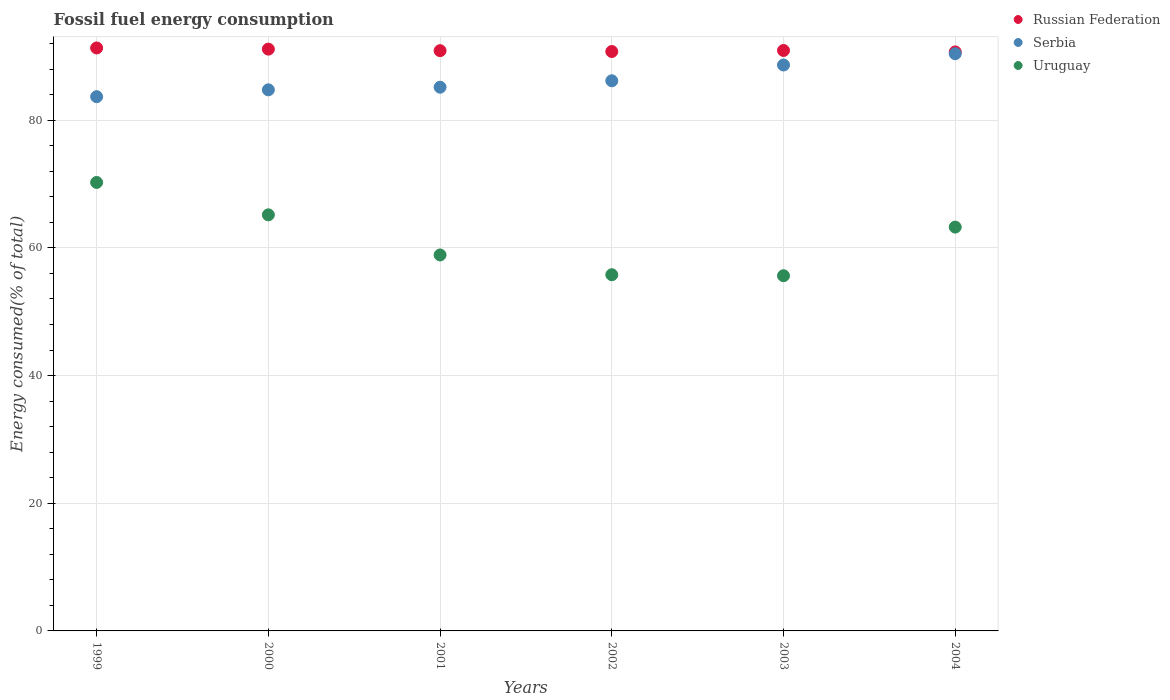Is the number of dotlines equal to the number of legend labels?
Offer a very short reply. Yes. What is the percentage of energy consumed in Russian Federation in 1999?
Your response must be concise. 91.31. Across all years, what is the maximum percentage of energy consumed in Uruguay?
Offer a very short reply. 70.25. Across all years, what is the minimum percentage of energy consumed in Russian Federation?
Provide a short and direct response. 90.69. In which year was the percentage of energy consumed in Russian Federation maximum?
Keep it short and to the point. 1999. What is the total percentage of energy consumed in Russian Federation in the graph?
Give a very brief answer. 545.68. What is the difference between the percentage of energy consumed in Russian Federation in 2000 and that in 2004?
Offer a very short reply. 0.44. What is the difference between the percentage of energy consumed in Russian Federation in 2002 and the percentage of energy consumed in Serbia in 2000?
Provide a short and direct response. 6. What is the average percentage of energy consumed in Russian Federation per year?
Offer a terse response. 90.95. In the year 1999, what is the difference between the percentage of energy consumed in Uruguay and percentage of energy consumed in Serbia?
Your response must be concise. -13.43. In how many years, is the percentage of energy consumed in Serbia greater than 40 %?
Offer a very short reply. 6. What is the ratio of the percentage of energy consumed in Russian Federation in 2002 to that in 2003?
Offer a terse response. 1. Is the percentage of energy consumed in Uruguay in 2000 less than that in 2001?
Give a very brief answer. No. Is the difference between the percentage of energy consumed in Uruguay in 1999 and 2000 greater than the difference between the percentage of energy consumed in Serbia in 1999 and 2000?
Give a very brief answer. Yes. What is the difference between the highest and the second highest percentage of energy consumed in Russian Federation?
Your answer should be very brief. 0.18. What is the difference between the highest and the lowest percentage of energy consumed in Serbia?
Offer a terse response. 6.73. In how many years, is the percentage of energy consumed in Serbia greater than the average percentage of energy consumed in Serbia taken over all years?
Your answer should be very brief. 2. Is it the case that in every year, the sum of the percentage of energy consumed in Uruguay and percentage of energy consumed in Serbia  is greater than the percentage of energy consumed in Russian Federation?
Make the answer very short. Yes. Is the percentage of energy consumed in Serbia strictly less than the percentage of energy consumed in Uruguay over the years?
Provide a succinct answer. No. How many dotlines are there?
Offer a terse response. 3. What is the difference between two consecutive major ticks on the Y-axis?
Provide a short and direct response. 20. Are the values on the major ticks of Y-axis written in scientific E-notation?
Offer a terse response. No. Does the graph contain grids?
Give a very brief answer. Yes. Where does the legend appear in the graph?
Give a very brief answer. Top right. How many legend labels are there?
Ensure brevity in your answer.  3. How are the legend labels stacked?
Your response must be concise. Vertical. What is the title of the graph?
Make the answer very short. Fossil fuel energy consumption. What is the label or title of the X-axis?
Provide a succinct answer. Years. What is the label or title of the Y-axis?
Ensure brevity in your answer.  Energy consumed(% of total). What is the Energy consumed(% of total) in Russian Federation in 1999?
Your answer should be very brief. 91.31. What is the Energy consumed(% of total) in Serbia in 1999?
Offer a very short reply. 83.68. What is the Energy consumed(% of total) of Uruguay in 1999?
Keep it short and to the point. 70.25. What is the Energy consumed(% of total) in Russian Federation in 2000?
Provide a succinct answer. 91.13. What is the Energy consumed(% of total) of Serbia in 2000?
Provide a short and direct response. 84.75. What is the Energy consumed(% of total) in Uruguay in 2000?
Provide a succinct answer. 65.17. What is the Energy consumed(% of total) of Russian Federation in 2001?
Provide a succinct answer. 90.89. What is the Energy consumed(% of total) in Serbia in 2001?
Provide a succinct answer. 85.16. What is the Energy consumed(% of total) in Uruguay in 2001?
Offer a terse response. 58.89. What is the Energy consumed(% of total) in Russian Federation in 2002?
Make the answer very short. 90.75. What is the Energy consumed(% of total) of Serbia in 2002?
Make the answer very short. 86.17. What is the Energy consumed(% of total) of Uruguay in 2002?
Provide a succinct answer. 55.79. What is the Energy consumed(% of total) in Russian Federation in 2003?
Provide a short and direct response. 90.92. What is the Energy consumed(% of total) of Serbia in 2003?
Make the answer very short. 88.64. What is the Energy consumed(% of total) of Uruguay in 2003?
Keep it short and to the point. 55.63. What is the Energy consumed(% of total) in Russian Federation in 2004?
Your response must be concise. 90.69. What is the Energy consumed(% of total) of Serbia in 2004?
Give a very brief answer. 90.41. What is the Energy consumed(% of total) in Uruguay in 2004?
Keep it short and to the point. 63.25. Across all years, what is the maximum Energy consumed(% of total) of Russian Federation?
Keep it short and to the point. 91.31. Across all years, what is the maximum Energy consumed(% of total) of Serbia?
Offer a terse response. 90.41. Across all years, what is the maximum Energy consumed(% of total) in Uruguay?
Give a very brief answer. 70.25. Across all years, what is the minimum Energy consumed(% of total) of Russian Federation?
Ensure brevity in your answer.  90.69. Across all years, what is the minimum Energy consumed(% of total) of Serbia?
Keep it short and to the point. 83.68. Across all years, what is the minimum Energy consumed(% of total) in Uruguay?
Ensure brevity in your answer.  55.63. What is the total Energy consumed(% of total) in Russian Federation in the graph?
Your response must be concise. 545.68. What is the total Energy consumed(% of total) of Serbia in the graph?
Keep it short and to the point. 518.81. What is the total Energy consumed(% of total) of Uruguay in the graph?
Provide a short and direct response. 368.98. What is the difference between the Energy consumed(% of total) in Russian Federation in 1999 and that in 2000?
Ensure brevity in your answer.  0.18. What is the difference between the Energy consumed(% of total) in Serbia in 1999 and that in 2000?
Your answer should be compact. -1.07. What is the difference between the Energy consumed(% of total) of Uruguay in 1999 and that in 2000?
Your answer should be compact. 5.07. What is the difference between the Energy consumed(% of total) in Russian Federation in 1999 and that in 2001?
Ensure brevity in your answer.  0.42. What is the difference between the Energy consumed(% of total) of Serbia in 1999 and that in 2001?
Your answer should be compact. -1.48. What is the difference between the Energy consumed(% of total) of Uruguay in 1999 and that in 2001?
Keep it short and to the point. 11.36. What is the difference between the Energy consumed(% of total) of Russian Federation in 1999 and that in 2002?
Give a very brief answer. 0.56. What is the difference between the Energy consumed(% of total) in Serbia in 1999 and that in 2002?
Make the answer very short. -2.49. What is the difference between the Energy consumed(% of total) in Uruguay in 1999 and that in 2002?
Provide a succinct answer. 14.46. What is the difference between the Energy consumed(% of total) in Russian Federation in 1999 and that in 2003?
Give a very brief answer. 0.39. What is the difference between the Energy consumed(% of total) in Serbia in 1999 and that in 2003?
Your answer should be compact. -4.96. What is the difference between the Energy consumed(% of total) in Uruguay in 1999 and that in 2003?
Provide a short and direct response. 14.61. What is the difference between the Energy consumed(% of total) of Russian Federation in 1999 and that in 2004?
Offer a terse response. 0.62. What is the difference between the Energy consumed(% of total) of Serbia in 1999 and that in 2004?
Your answer should be very brief. -6.73. What is the difference between the Energy consumed(% of total) in Uruguay in 1999 and that in 2004?
Make the answer very short. 6.99. What is the difference between the Energy consumed(% of total) of Russian Federation in 2000 and that in 2001?
Give a very brief answer. 0.24. What is the difference between the Energy consumed(% of total) of Serbia in 2000 and that in 2001?
Offer a very short reply. -0.41. What is the difference between the Energy consumed(% of total) of Uruguay in 2000 and that in 2001?
Offer a terse response. 6.29. What is the difference between the Energy consumed(% of total) of Russian Federation in 2000 and that in 2002?
Offer a terse response. 0.37. What is the difference between the Energy consumed(% of total) in Serbia in 2000 and that in 2002?
Offer a terse response. -1.42. What is the difference between the Energy consumed(% of total) in Uruguay in 2000 and that in 2002?
Your answer should be very brief. 9.38. What is the difference between the Energy consumed(% of total) of Russian Federation in 2000 and that in 2003?
Your answer should be very brief. 0.21. What is the difference between the Energy consumed(% of total) of Serbia in 2000 and that in 2003?
Make the answer very short. -3.89. What is the difference between the Energy consumed(% of total) in Uruguay in 2000 and that in 2003?
Give a very brief answer. 9.54. What is the difference between the Energy consumed(% of total) of Russian Federation in 2000 and that in 2004?
Your answer should be very brief. 0.44. What is the difference between the Energy consumed(% of total) of Serbia in 2000 and that in 2004?
Keep it short and to the point. -5.66. What is the difference between the Energy consumed(% of total) of Uruguay in 2000 and that in 2004?
Give a very brief answer. 1.92. What is the difference between the Energy consumed(% of total) of Russian Federation in 2001 and that in 2002?
Offer a very short reply. 0.13. What is the difference between the Energy consumed(% of total) of Serbia in 2001 and that in 2002?
Offer a terse response. -1. What is the difference between the Energy consumed(% of total) of Uruguay in 2001 and that in 2002?
Give a very brief answer. 3.1. What is the difference between the Energy consumed(% of total) of Russian Federation in 2001 and that in 2003?
Give a very brief answer. -0.03. What is the difference between the Energy consumed(% of total) in Serbia in 2001 and that in 2003?
Give a very brief answer. -3.48. What is the difference between the Energy consumed(% of total) in Uruguay in 2001 and that in 2003?
Provide a succinct answer. 3.25. What is the difference between the Energy consumed(% of total) of Russian Federation in 2001 and that in 2004?
Keep it short and to the point. 0.2. What is the difference between the Energy consumed(% of total) of Serbia in 2001 and that in 2004?
Offer a very short reply. -5.25. What is the difference between the Energy consumed(% of total) of Uruguay in 2001 and that in 2004?
Offer a terse response. -4.36. What is the difference between the Energy consumed(% of total) in Russian Federation in 2002 and that in 2003?
Provide a succinct answer. -0.16. What is the difference between the Energy consumed(% of total) of Serbia in 2002 and that in 2003?
Ensure brevity in your answer.  -2.47. What is the difference between the Energy consumed(% of total) in Uruguay in 2002 and that in 2003?
Ensure brevity in your answer.  0.16. What is the difference between the Energy consumed(% of total) of Russian Federation in 2002 and that in 2004?
Provide a short and direct response. 0.06. What is the difference between the Energy consumed(% of total) of Serbia in 2002 and that in 2004?
Provide a short and direct response. -4.24. What is the difference between the Energy consumed(% of total) in Uruguay in 2002 and that in 2004?
Provide a short and direct response. -7.46. What is the difference between the Energy consumed(% of total) in Russian Federation in 2003 and that in 2004?
Your answer should be very brief. 0.23. What is the difference between the Energy consumed(% of total) of Serbia in 2003 and that in 2004?
Ensure brevity in your answer.  -1.77. What is the difference between the Energy consumed(% of total) of Uruguay in 2003 and that in 2004?
Provide a succinct answer. -7.62. What is the difference between the Energy consumed(% of total) of Russian Federation in 1999 and the Energy consumed(% of total) of Serbia in 2000?
Your answer should be very brief. 6.56. What is the difference between the Energy consumed(% of total) in Russian Federation in 1999 and the Energy consumed(% of total) in Uruguay in 2000?
Offer a very short reply. 26.14. What is the difference between the Energy consumed(% of total) of Serbia in 1999 and the Energy consumed(% of total) of Uruguay in 2000?
Your answer should be compact. 18.5. What is the difference between the Energy consumed(% of total) of Russian Federation in 1999 and the Energy consumed(% of total) of Serbia in 2001?
Offer a very short reply. 6.15. What is the difference between the Energy consumed(% of total) in Russian Federation in 1999 and the Energy consumed(% of total) in Uruguay in 2001?
Provide a succinct answer. 32.42. What is the difference between the Energy consumed(% of total) in Serbia in 1999 and the Energy consumed(% of total) in Uruguay in 2001?
Provide a succinct answer. 24.79. What is the difference between the Energy consumed(% of total) of Russian Federation in 1999 and the Energy consumed(% of total) of Serbia in 2002?
Offer a very short reply. 5.14. What is the difference between the Energy consumed(% of total) of Russian Federation in 1999 and the Energy consumed(% of total) of Uruguay in 2002?
Make the answer very short. 35.52. What is the difference between the Energy consumed(% of total) in Serbia in 1999 and the Energy consumed(% of total) in Uruguay in 2002?
Your answer should be compact. 27.89. What is the difference between the Energy consumed(% of total) of Russian Federation in 1999 and the Energy consumed(% of total) of Serbia in 2003?
Ensure brevity in your answer.  2.67. What is the difference between the Energy consumed(% of total) of Russian Federation in 1999 and the Energy consumed(% of total) of Uruguay in 2003?
Make the answer very short. 35.67. What is the difference between the Energy consumed(% of total) in Serbia in 1999 and the Energy consumed(% of total) in Uruguay in 2003?
Give a very brief answer. 28.04. What is the difference between the Energy consumed(% of total) in Russian Federation in 1999 and the Energy consumed(% of total) in Serbia in 2004?
Keep it short and to the point. 0.9. What is the difference between the Energy consumed(% of total) of Russian Federation in 1999 and the Energy consumed(% of total) of Uruguay in 2004?
Keep it short and to the point. 28.06. What is the difference between the Energy consumed(% of total) of Serbia in 1999 and the Energy consumed(% of total) of Uruguay in 2004?
Your answer should be compact. 20.43. What is the difference between the Energy consumed(% of total) in Russian Federation in 2000 and the Energy consumed(% of total) in Serbia in 2001?
Keep it short and to the point. 5.96. What is the difference between the Energy consumed(% of total) in Russian Federation in 2000 and the Energy consumed(% of total) in Uruguay in 2001?
Make the answer very short. 32.24. What is the difference between the Energy consumed(% of total) of Serbia in 2000 and the Energy consumed(% of total) of Uruguay in 2001?
Keep it short and to the point. 25.86. What is the difference between the Energy consumed(% of total) in Russian Federation in 2000 and the Energy consumed(% of total) in Serbia in 2002?
Your answer should be very brief. 4.96. What is the difference between the Energy consumed(% of total) in Russian Federation in 2000 and the Energy consumed(% of total) in Uruguay in 2002?
Your response must be concise. 35.34. What is the difference between the Energy consumed(% of total) of Serbia in 2000 and the Energy consumed(% of total) of Uruguay in 2002?
Keep it short and to the point. 28.96. What is the difference between the Energy consumed(% of total) in Russian Federation in 2000 and the Energy consumed(% of total) in Serbia in 2003?
Offer a terse response. 2.48. What is the difference between the Energy consumed(% of total) in Russian Federation in 2000 and the Energy consumed(% of total) in Uruguay in 2003?
Keep it short and to the point. 35.49. What is the difference between the Energy consumed(% of total) in Serbia in 2000 and the Energy consumed(% of total) in Uruguay in 2003?
Your answer should be very brief. 29.12. What is the difference between the Energy consumed(% of total) of Russian Federation in 2000 and the Energy consumed(% of total) of Serbia in 2004?
Your answer should be very brief. 0.72. What is the difference between the Energy consumed(% of total) in Russian Federation in 2000 and the Energy consumed(% of total) in Uruguay in 2004?
Give a very brief answer. 27.88. What is the difference between the Energy consumed(% of total) of Serbia in 2000 and the Energy consumed(% of total) of Uruguay in 2004?
Offer a very short reply. 21.5. What is the difference between the Energy consumed(% of total) in Russian Federation in 2001 and the Energy consumed(% of total) in Serbia in 2002?
Give a very brief answer. 4.72. What is the difference between the Energy consumed(% of total) of Russian Federation in 2001 and the Energy consumed(% of total) of Uruguay in 2002?
Keep it short and to the point. 35.1. What is the difference between the Energy consumed(% of total) of Serbia in 2001 and the Energy consumed(% of total) of Uruguay in 2002?
Give a very brief answer. 29.37. What is the difference between the Energy consumed(% of total) of Russian Federation in 2001 and the Energy consumed(% of total) of Serbia in 2003?
Your answer should be compact. 2.24. What is the difference between the Energy consumed(% of total) of Russian Federation in 2001 and the Energy consumed(% of total) of Uruguay in 2003?
Make the answer very short. 35.25. What is the difference between the Energy consumed(% of total) of Serbia in 2001 and the Energy consumed(% of total) of Uruguay in 2003?
Your answer should be very brief. 29.53. What is the difference between the Energy consumed(% of total) of Russian Federation in 2001 and the Energy consumed(% of total) of Serbia in 2004?
Give a very brief answer. 0.48. What is the difference between the Energy consumed(% of total) in Russian Federation in 2001 and the Energy consumed(% of total) in Uruguay in 2004?
Your answer should be very brief. 27.64. What is the difference between the Energy consumed(% of total) of Serbia in 2001 and the Energy consumed(% of total) of Uruguay in 2004?
Give a very brief answer. 21.91. What is the difference between the Energy consumed(% of total) in Russian Federation in 2002 and the Energy consumed(% of total) in Serbia in 2003?
Offer a very short reply. 2.11. What is the difference between the Energy consumed(% of total) of Russian Federation in 2002 and the Energy consumed(% of total) of Uruguay in 2003?
Provide a succinct answer. 35.12. What is the difference between the Energy consumed(% of total) in Serbia in 2002 and the Energy consumed(% of total) in Uruguay in 2003?
Make the answer very short. 30.53. What is the difference between the Energy consumed(% of total) in Russian Federation in 2002 and the Energy consumed(% of total) in Serbia in 2004?
Keep it short and to the point. 0.34. What is the difference between the Energy consumed(% of total) of Russian Federation in 2002 and the Energy consumed(% of total) of Uruguay in 2004?
Keep it short and to the point. 27.5. What is the difference between the Energy consumed(% of total) in Serbia in 2002 and the Energy consumed(% of total) in Uruguay in 2004?
Provide a short and direct response. 22.92. What is the difference between the Energy consumed(% of total) of Russian Federation in 2003 and the Energy consumed(% of total) of Serbia in 2004?
Your answer should be very brief. 0.51. What is the difference between the Energy consumed(% of total) of Russian Federation in 2003 and the Energy consumed(% of total) of Uruguay in 2004?
Provide a succinct answer. 27.66. What is the difference between the Energy consumed(% of total) in Serbia in 2003 and the Energy consumed(% of total) in Uruguay in 2004?
Provide a short and direct response. 25.39. What is the average Energy consumed(% of total) in Russian Federation per year?
Your answer should be very brief. 90.95. What is the average Energy consumed(% of total) in Serbia per year?
Make the answer very short. 86.47. What is the average Energy consumed(% of total) in Uruguay per year?
Your answer should be compact. 61.5. In the year 1999, what is the difference between the Energy consumed(% of total) of Russian Federation and Energy consumed(% of total) of Serbia?
Give a very brief answer. 7.63. In the year 1999, what is the difference between the Energy consumed(% of total) in Russian Federation and Energy consumed(% of total) in Uruguay?
Keep it short and to the point. 21.06. In the year 1999, what is the difference between the Energy consumed(% of total) in Serbia and Energy consumed(% of total) in Uruguay?
Your answer should be compact. 13.43. In the year 2000, what is the difference between the Energy consumed(% of total) in Russian Federation and Energy consumed(% of total) in Serbia?
Your answer should be compact. 6.37. In the year 2000, what is the difference between the Energy consumed(% of total) in Russian Federation and Energy consumed(% of total) in Uruguay?
Offer a very short reply. 25.95. In the year 2000, what is the difference between the Energy consumed(% of total) in Serbia and Energy consumed(% of total) in Uruguay?
Give a very brief answer. 19.58. In the year 2001, what is the difference between the Energy consumed(% of total) in Russian Federation and Energy consumed(% of total) in Serbia?
Provide a short and direct response. 5.72. In the year 2001, what is the difference between the Energy consumed(% of total) in Russian Federation and Energy consumed(% of total) in Uruguay?
Offer a terse response. 32. In the year 2001, what is the difference between the Energy consumed(% of total) in Serbia and Energy consumed(% of total) in Uruguay?
Offer a very short reply. 26.27. In the year 2002, what is the difference between the Energy consumed(% of total) in Russian Federation and Energy consumed(% of total) in Serbia?
Offer a very short reply. 4.59. In the year 2002, what is the difference between the Energy consumed(% of total) in Russian Federation and Energy consumed(% of total) in Uruguay?
Give a very brief answer. 34.96. In the year 2002, what is the difference between the Energy consumed(% of total) of Serbia and Energy consumed(% of total) of Uruguay?
Your response must be concise. 30.38. In the year 2003, what is the difference between the Energy consumed(% of total) in Russian Federation and Energy consumed(% of total) in Serbia?
Give a very brief answer. 2.27. In the year 2003, what is the difference between the Energy consumed(% of total) of Russian Federation and Energy consumed(% of total) of Uruguay?
Offer a terse response. 35.28. In the year 2003, what is the difference between the Energy consumed(% of total) of Serbia and Energy consumed(% of total) of Uruguay?
Make the answer very short. 33.01. In the year 2004, what is the difference between the Energy consumed(% of total) in Russian Federation and Energy consumed(% of total) in Serbia?
Your answer should be very brief. 0.28. In the year 2004, what is the difference between the Energy consumed(% of total) of Russian Federation and Energy consumed(% of total) of Uruguay?
Your response must be concise. 27.44. In the year 2004, what is the difference between the Energy consumed(% of total) in Serbia and Energy consumed(% of total) in Uruguay?
Keep it short and to the point. 27.16. What is the ratio of the Energy consumed(% of total) in Russian Federation in 1999 to that in 2000?
Your response must be concise. 1. What is the ratio of the Energy consumed(% of total) of Serbia in 1999 to that in 2000?
Provide a succinct answer. 0.99. What is the ratio of the Energy consumed(% of total) in Uruguay in 1999 to that in 2000?
Offer a terse response. 1.08. What is the ratio of the Energy consumed(% of total) of Russian Federation in 1999 to that in 2001?
Make the answer very short. 1. What is the ratio of the Energy consumed(% of total) of Serbia in 1999 to that in 2001?
Offer a terse response. 0.98. What is the ratio of the Energy consumed(% of total) in Uruguay in 1999 to that in 2001?
Provide a short and direct response. 1.19. What is the ratio of the Energy consumed(% of total) of Russian Federation in 1999 to that in 2002?
Your answer should be very brief. 1.01. What is the ratio of the Energy consumed(% of total) of Serbia in 1999 to that in 2002?
Offer a terse response. 0.97. What is the ratio of the Energy consumed(% of total) in Uruguay in 1999 to that in 2002?
Make the answer very short. 1.26. What is the ratio of the Energy consumed(% of total) of Russian Federation in 1999 to that in 2003?
Offer a very short reply. 1. What is the ratio of the Energy consumed(% of total) of Serbia in 1999 to that in 2003?
Provide a succinct answer. 0.94. What is the ratio of the Energy consumed(% of total) of Uruguay in 1999 to that in 2003?
Your answer should be compact. 1.26. What is the ratio of the Energy consumed(% of total) of Russian Federation in 1999 to that in 2004?
Provide a short and direct response. 1.01. What is the ratio of the Energy consumed(% of total) of Serbia in 1999 to that in 2004?
Provide a short and direct response. 0.93. What is the ratio of the Energy consumed(% of total) of Uruguay in 1999 to that in 2004?
Make the answer very short. 1.11. What is the ratio of the Energy consumed(% of total) in Serbia in 2000 to that in 2001?
Keep it short and to the point. 1. What is the ratio of the Energy consumed(% of total) in Uruguay in 2000 to that in 2001?
Offer a very short reply. 1.11. What is the ratio of the Energy consumed(% of total) of Russian Federation in 2000 to that in 2002?
Make the answer very short. 1. What is the ratio of the Energy consumed(% of total) in Serbia in 2000 to that in 2002?
Offer a very short reply. 0.98. What is the ratio of the Energy consumed(% of total) in Uruguay in 2000 to that in 2002?
Give a very brief answer. 1.17. What is the ratio of the Energy consumed(% of total) in Serbia in 2000 to that in 2003?
Offer a very short reply. 0.96. What is the ratio of the Energy consumed(% of total) of Uruguay in 2000 to that in 2003?
Offer a very short reply. 1.17. What is the ratio of the Energy consumed(% of total) of Russian Federation in 2000 to that in 2004?
Make the answer very short. 1. What is the ratio of the Energy consumed(% of total) in Serbia in 2000 to that in 2004?
Offer a terse response. 0.94. What is the ratio of the Energy consumed(% of total) of Uruguay in 2000 to that in 2004?
Offer a very short reply. 1.03. What is the ratio of the Energy consumed(% of total) in Russian Federation in 2001 to that in 2002?
Your response must be concise. 1. What is the ratio of the Energy consumed(% of total) of Serbia in 2001 to that in 2002?
Keep it short and to the point. 0.99. What is the ratio of the Energy consumed(% of total) in Uruguay in 2001 to that in 2002?
Offer a terse response. 1.06. What is the ratio of the Energy consumed(% of total) of Russian Federation in 2001 to that in 2003?
Offer a terse response. 1. What is the ratio of the Energy consumed(% of total) of Serbia in 2001 to that in 2003?
Your answer should be compact. 0.96. What is the ratio of the Energy consumed(% of total) in Uruguay in 2001 to that in 2003?
Offer a terse response. 1.06. What is the ratio of the Energy consumed(% of total) of Russian Federation in 2001 to that in 2004?
Provide a succinct answer. 1. What is the ratio of the Energy consumed(% of total) of Serbia in 2001 to that in 2004?
Your answer should be very brief. 0.94. What is the ratio of the Energy consumed(% of total) in Uruguay in 2001 to that in 2004?
Keep it short and to the point. 0.93. What is the ratio of the Energy consumed(% of total) of Serbia in 2002 to that in 2003?
Keep it short and to the point. 0.97. What is the ratio of the Energy consumed(% of total) in Russian Federation in 2002 to that in 2004?
Provide a short and direct response. 1. What is the ratio of the Energy consumed(% of total) in Serbia in 2002 to that in 2004?
Keep it short and to the point. 0.95. What is the ratio of the Energy consumed(% of total) in Uruguay in 2002 to that in 2004?
Your response must be concise. 0.88. What is the ratio of the Energy consumed(% of total) in Serbia in 2003 to that in 2004?
Provide a short and direct response. 0.98. What is the ratio of the Energy consumed(% of total) in Uruguay in 2003 to that in 2004?
Give a very brief answer. 0.88. What is the difference between the highest and the second highest Energy consumed(% of total) in Russian Federation?
Offer a terse response. 0.18. What is the difference between the highest and the second highest Energy consumed(% of total) in Serbia?
Your response must be concise. 1.77. What is the difference between the highest and the second highest Energy consumed(% of total) in Uruguay?
Keep it short and to the point. 5.07. What is the difference between the highest and the lowest Energy consumed(% of total) of Russian Federation?
Your answer should be compact. 0.62. What is the difference between the highest and the lowest Energy consumed(% of total) of Serbia?
Ensure brevity in your answer.  6.73. What is the difference between the highest and the lowest Energy consumed(% of total) of Uruguay?
Keep it short and to the point. 14.61. 